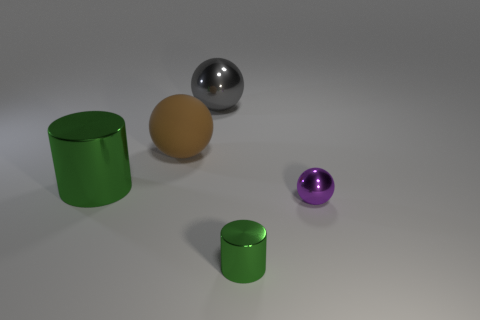Add 1 green things. How many objects exist? 6 Subtract all cylinders. How many objects are left? 3 Subtract all tiny green metal cylinders. Subtract all matte balls. How many objects are left? 3 Add 5 large green shiny objects. How many large green shiny objects are left? 6 Add 4 yellow metal cubes. How many yellow metal cubes exist? 4 Subtract 0 purple blocks. How many objects are left? 5 